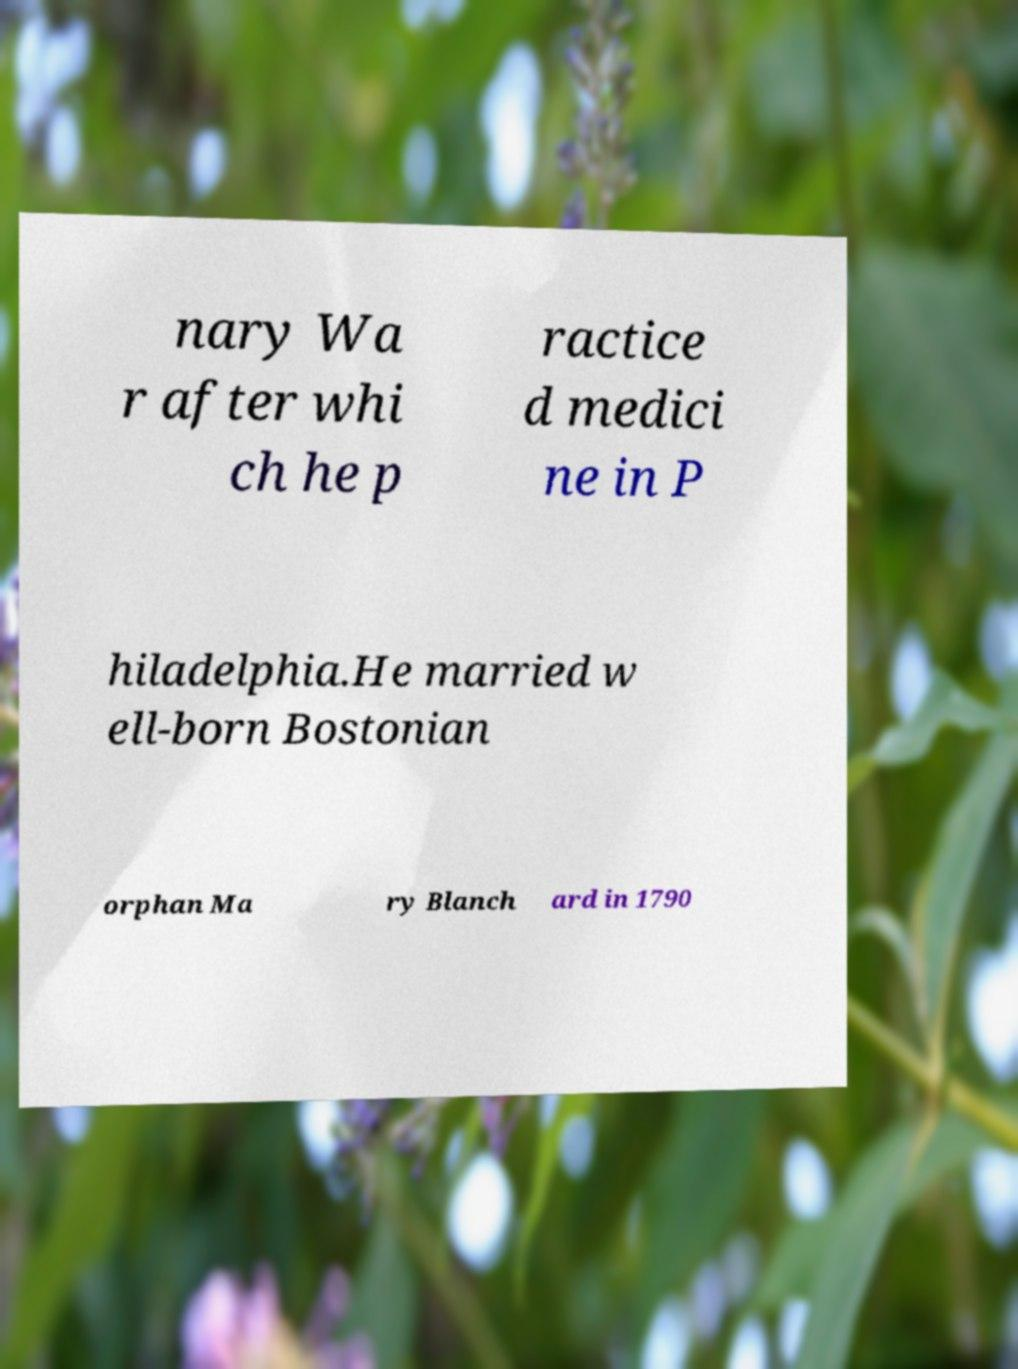Please read and relay the text visible in this image. What does it say? nary Wa r after whi ch he p ractice d medici ne in P hiladelphia.He married w ell-born Bostonian orphan Ma ry Blanch ard in 1790 